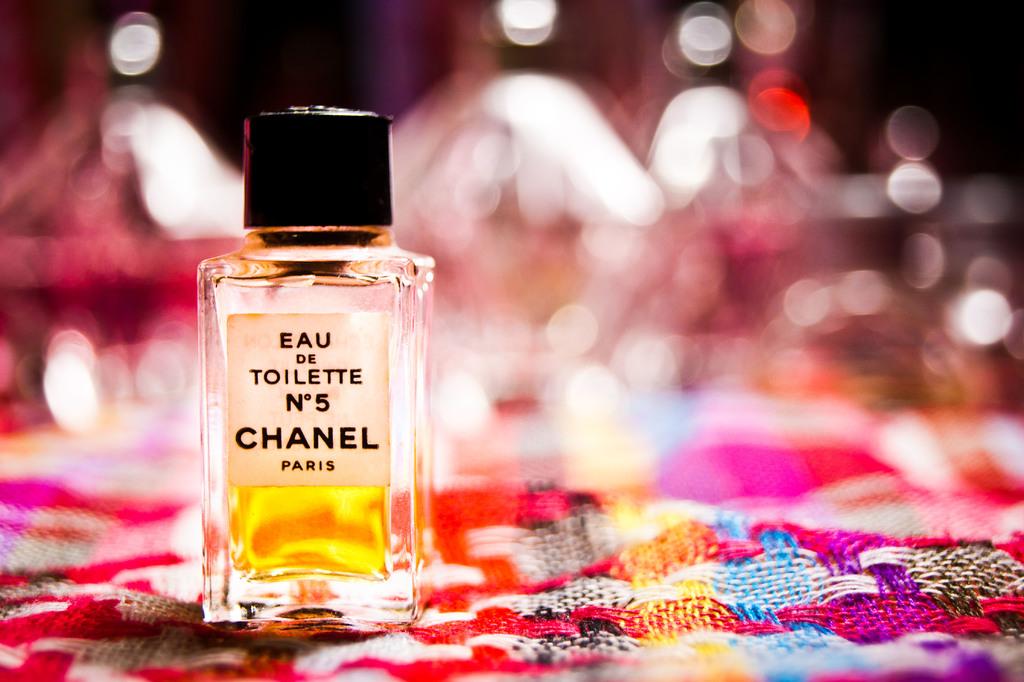Where is this brand from?
Your response must be concise. Paris. 